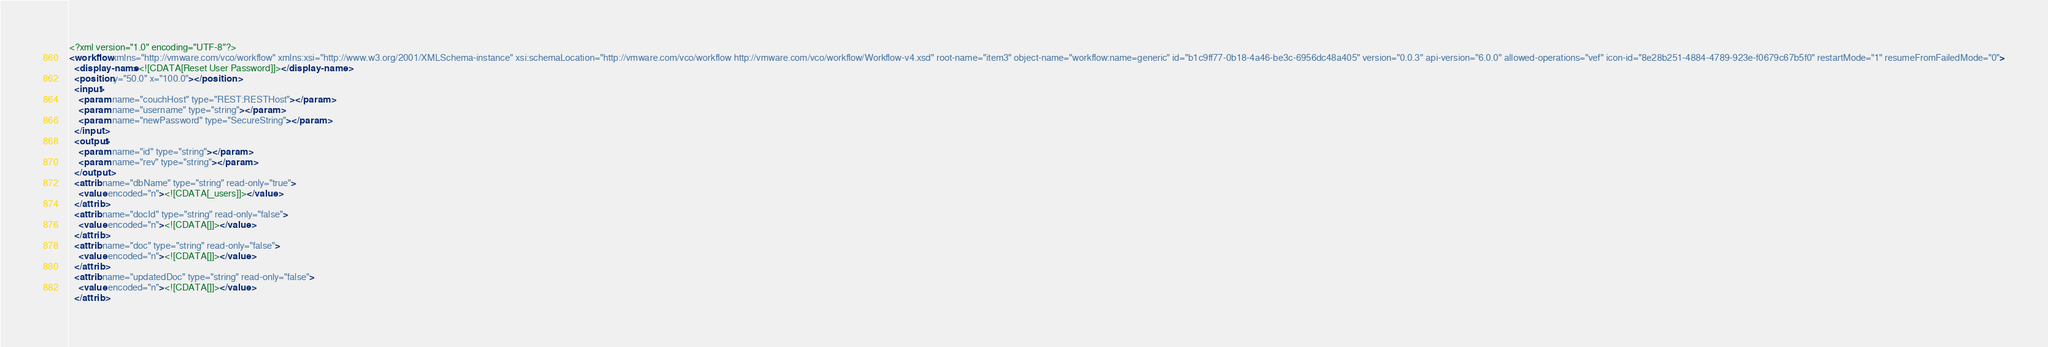<code> <loc_0><loc_0><loc_500><loc_500><_XML_><?xml version="1.0" encoding="UTF-8"?>
<workflow xmlns="http://vmware.com/vco/workflow" xmlns:xsi="http://www.w3.org/2001/XMLSchema-instance" xsi:schemaLocation="http://vmware.com/vco/workflow http://vmware.com/vco/workflow/Workflow-v4.xsd" root-name="item3" object-name="workflow:name=generic" id="b1c9ff77-0b18-4a46-be3c-6956dc48a405" version="0.0.3" api-version="6.0.0" allowed-operations="vef" icon-id="8e28b251-4884-4789-923e-f0679c67b5f0" restartMode="1" resumeFromFailedMode="0">
  <display-name><![CDATA[Reset User Password]]></display-name>
  <position y="50.0" x="100.0"></position>
  <input>
    <param name="couchHost" type="REST:RESTHost"></param>
    <param name="username" type="string"></param>
    <param name="newPassword" type="SecureString"></param>
  </input>
  <output>
    <param name="id" type="string"></param>
    <param name="rev" type="string"></param>
  </output>
  <attrib name="dbName" type="string" read-only="true">
    <value encoded="n"><![CDATA[_users]]></value>
  </attrib>
  <attrib name="docId" type="string" read-only="false">
    <value encoded="n"><![CDATA[]]></value>
  </attrib>
  <attrib name="doc" type="string" read-only="false">
    <value encoded="n"><![CDATA[]]></value>
  </attrib>
  <attrib name="updatedDoc" type="string" read-only="false">
    <value encoded="n"><![CDATA[]]></value>
  </attrib></code> 